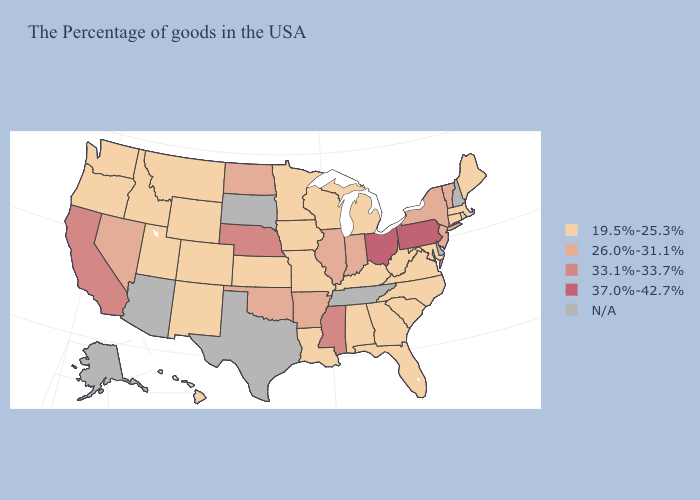Which states have the lowest value in the USA?
Short answer required. Maine, Massachusetts, Rhode Island, Connecticut, Maryland, Virginia, North Carolina, South Carolina, West Virginia, Florida, Georgia, Michigan, Kentucky, Alabama, Wisconsin, Louisiana, Missouri, Minnesota, Iowa, Kansas, Wyoming, Colorado, New Mexico, Utah, Montana, Idaho, Washington, Oregon, Hawaii. What is the value of Texas?
Keep it brief. N/A. What is the lowest value in the MidWest?
Quick response, please. 19.5%-25.3%. Name the states that have a value in the range 37.0%-42.7%?
Write a very short answer. Pennsylvania, Ohio. What is the highest value in the USA?
Short answer required. 37.0%-42.7%. What is the value of Montana?
Quick response, please. 19.5%-25.3%. Name the states that have a value in the range 19.5%-25.3%?
Concise answer only. Maine, Massachusetts, Rhode Island, Connecticut, Maryland, Virginia, North Carolina, South Carolina, West Virginia, Florida, Georgia, Michigan, Kentucky, Alabama, Wisconsin, Louisiana, Missouri, Minnesota, Iowa, Kansas, Wyoming, Colorado, New Mexico, Utah, Montana, Idaho, Washington, Oregon, Hawaii. Name the states that have a value in the range 26.0%-31.1%?
Short answer required. Vermont, New York, New Jersey, Indiana, Illinois, Arkansas, Oklahoma, North Dakota, Nevada. Does the map have missing data?
Quick response, please. Yes. How many symbols are there in the legend?
Give a very brief answer. 5. Among the states that border Nevada , does Oregon have the highest value?
Answer briefly. No. Does the first symbol in the legend represent the smallest category?
Be succinct. Yes. Among the states that border Iowa , which have the highest value?
Answer briefly. Nebraska. Among the states that border Tennessee , which have the highest value?
Short answer required. Mississippi. Name the states that have a value in the range 26.0%-31.1%?
Give a very brief answer. Vermont, New York, New Jersey, Indiana, Illinois, Arkansas, Oklahoma, North Dakota, Nevada. 